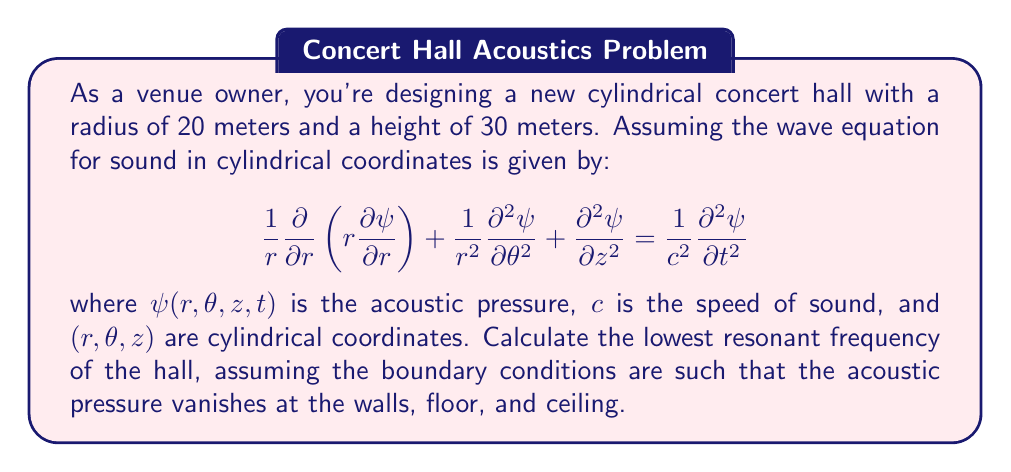Give your solution to this math problem. To solve this problem, we'll follow these steps:

1) The general solution for the wave equation in cylindrical coordinates can be written as:

   $$ \psi(r,\theta,z,t) = [AJ_m(k_r r) + BY_m(k_r r)][C\cos(m\theta) + D\sin(m\theta)][E\cos(k_z z) + F\sin(k_z z)]e^{i\omega t} $$

   where $J_m$ and $Y_m$ are Bessel functions of the first and second kind, respectively.

2) Given the boundary conditions, we can simplify this solution. The pressure vanishing at the walls means $\psi(R,\theta,z,t) = 0$, where $R = 20$ m is the radius. This gives us:

   $$ J_m(k_r R) = 0 $$

3) The lowest resonant frequency will correspond to the smallest value of $k_r$ that satisfies this equation. This occurs when $m = 0$ and $k_r R$ is the first zero of $J_0$, which is approximately 2.405.

4) So, $k_r = 2.405/R = 2.405/20 = 0.12025$ m^(-1)

5) For the z-direction, the boundary conditions give us:

   $$ k_z = \frac{\pi}{H} = \frac{\pi}{30} = 0.1047 $$ m^(-1)

6) The resonant frequency is related to these wavenumbers by:

   $$ \omega^2 = c^2(k_r^2 + k_z^2) $$

7) Substituting the values (and using $c = 343$ m/s for the speed of sound in air):

   $$ \omega^2 = 343^2(0.12025^2 + 0.1047^2) = 2997.3 $$ s^(-2)

8) Therefore, $\omega = \sqrt{2997.3} = 54.75$ rad/s

9) Converting to frequency:

   $$ f = \frac{\omega}{2\pi} = \frac{54.75}{2\pi} = 8.71 $$ Hz
Answer: 8.71 Hz 